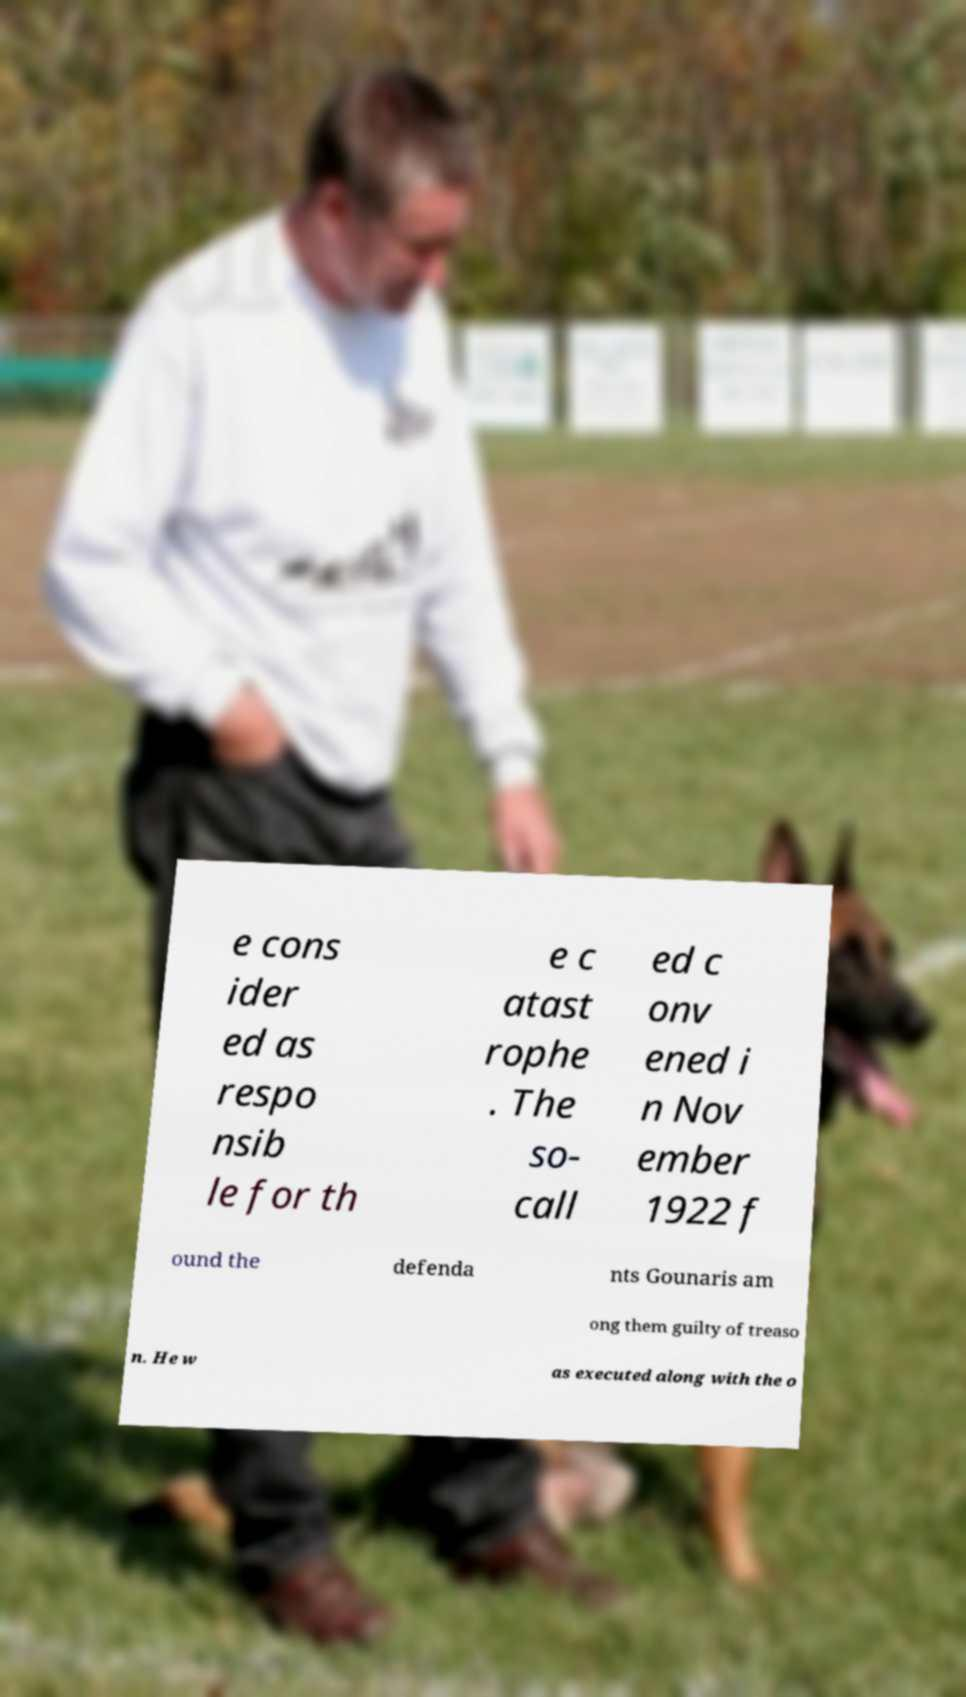What messages or text are displayed in this image? I need them in a readable, typed format. e cons ider ed as respo nsib le for th e c atast rophe . The so- call ed c onv ened i n Nov ember 1922 f ound the defenda nts Gounaris am ong them guilty of treaso n. He w as executed along with the o 